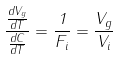<formula> <loc_0><loc_0><loc_500><loc_500>\frac { \frac { d V _ { g } } { d T } } { \frac { d C } { d T } } = \frac { 1 } { F _ { i } } = \frac { V _ { g } } { V _ { i } }</formula> 